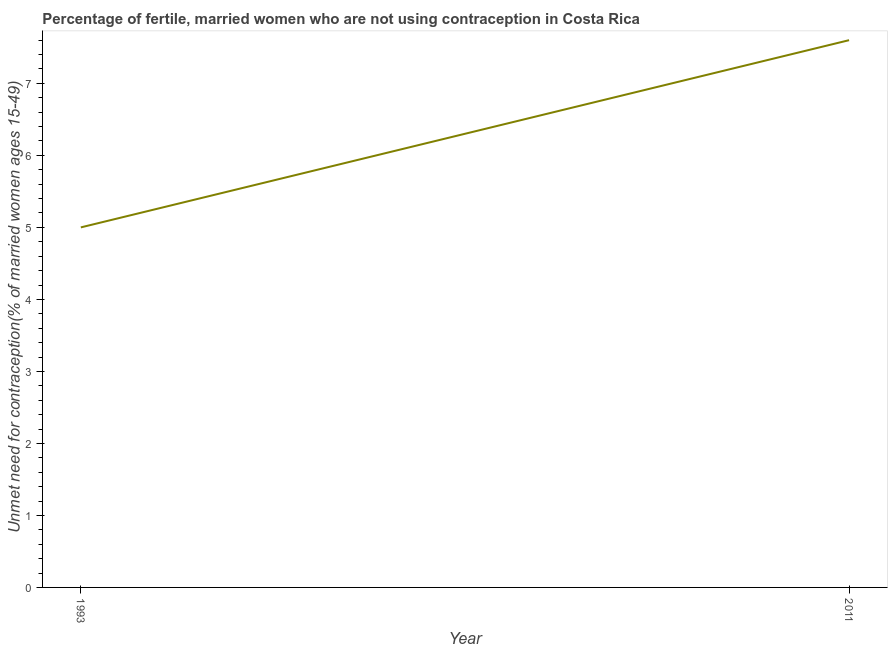In which year was the number of married women who are not using contraception minimum?
Your answer should be compact. 1993. What is the sum of the number of married women who are not using contraception?
Provide a succinct answer. 12.6. What is the difference between the number of married women who are not using contraception in 1993 and 2011?
Make the answer very short. -2.6. In how many years, is the number of married women who are not using contraception greater than 3.4 %?
Your answer should be very brief. 2. What is the ratio of the number of married women who are not using contraception in 1993 to that in 2011?
Offer a terse response. 0.66. Is the number of married women who are not using contraception in 1993 less than that in 2011?
Give a very brief answer. Yes. In how many years, is the number of married women who are not using contraception greater than the average number of married women who are not using contraception taken over all years?
Provide a succinct answer. 1. How many lines are there?
Offer a very short reply. 1. Does the graph contain any zero values?
Offer a terse response. No. Does the graph contain grids?
Offer a terse response. No. What is the title of the graph?
Your answer should be compact. Percentage of fertile, married women who are not using contraception in Costa Rica. What is the label or title of the Y-axis?
Offer a very short reply.  Unmet need for contraception(% of married women ages 15-49). What is the  Unmet need for contraception(% of married women ages 15-49) in 1993?
Offer a terse response. 5. What is the  Unmet need for contraception(% of married women ages 15-49) in 2011?
Ensure brevity in your answer.  7.6. What is the ratio of the  Unmet need for contraception(% of married women ages 15-49) in 1993 to that in 2011?
Keep it short and to the point. 0.66. 